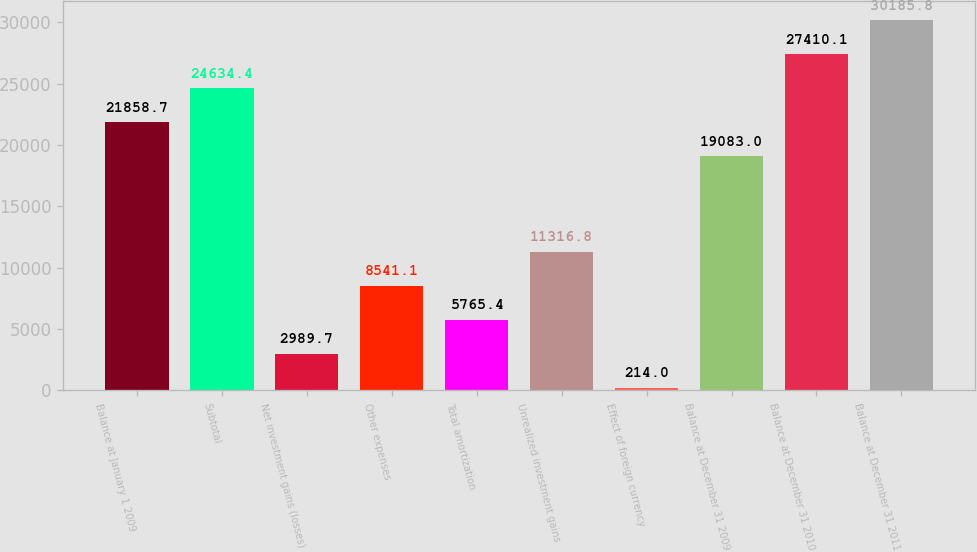Convert chart to OTSL. <chart><loc_0><loc_0><loc_500><loc_500><bar_chart><fcel>Balance at January 1 2009<fcel>Subtotal<fcel>Net investment gains (losses)<fcel>Other expenses<fcel>Total amortization<fcel>Unrealized investment gains<fcel>Effect of foreign currency<fcel>Balance at December 31 2009<fcel>Balance at December 31 2010<fcel>Balance at December 31 2011<nl><fcel>21858.7<fcel>24634.4<fcel>2989.7<fcel>8541.1<fcel>5765.4<fcel>11316.8<fcel>214<fcel>19083<fcel>27410.1<fcel>30185.8<nl></chart> 